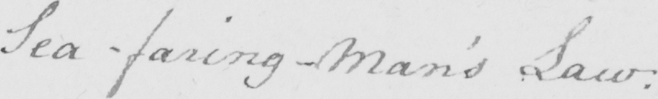Transcribe the text shown in this historical manuscript line. Sea-faring-Man ' s Law : 